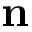<formula> <loc_0><loc_0><loc_500><loc_500>n</formula> 